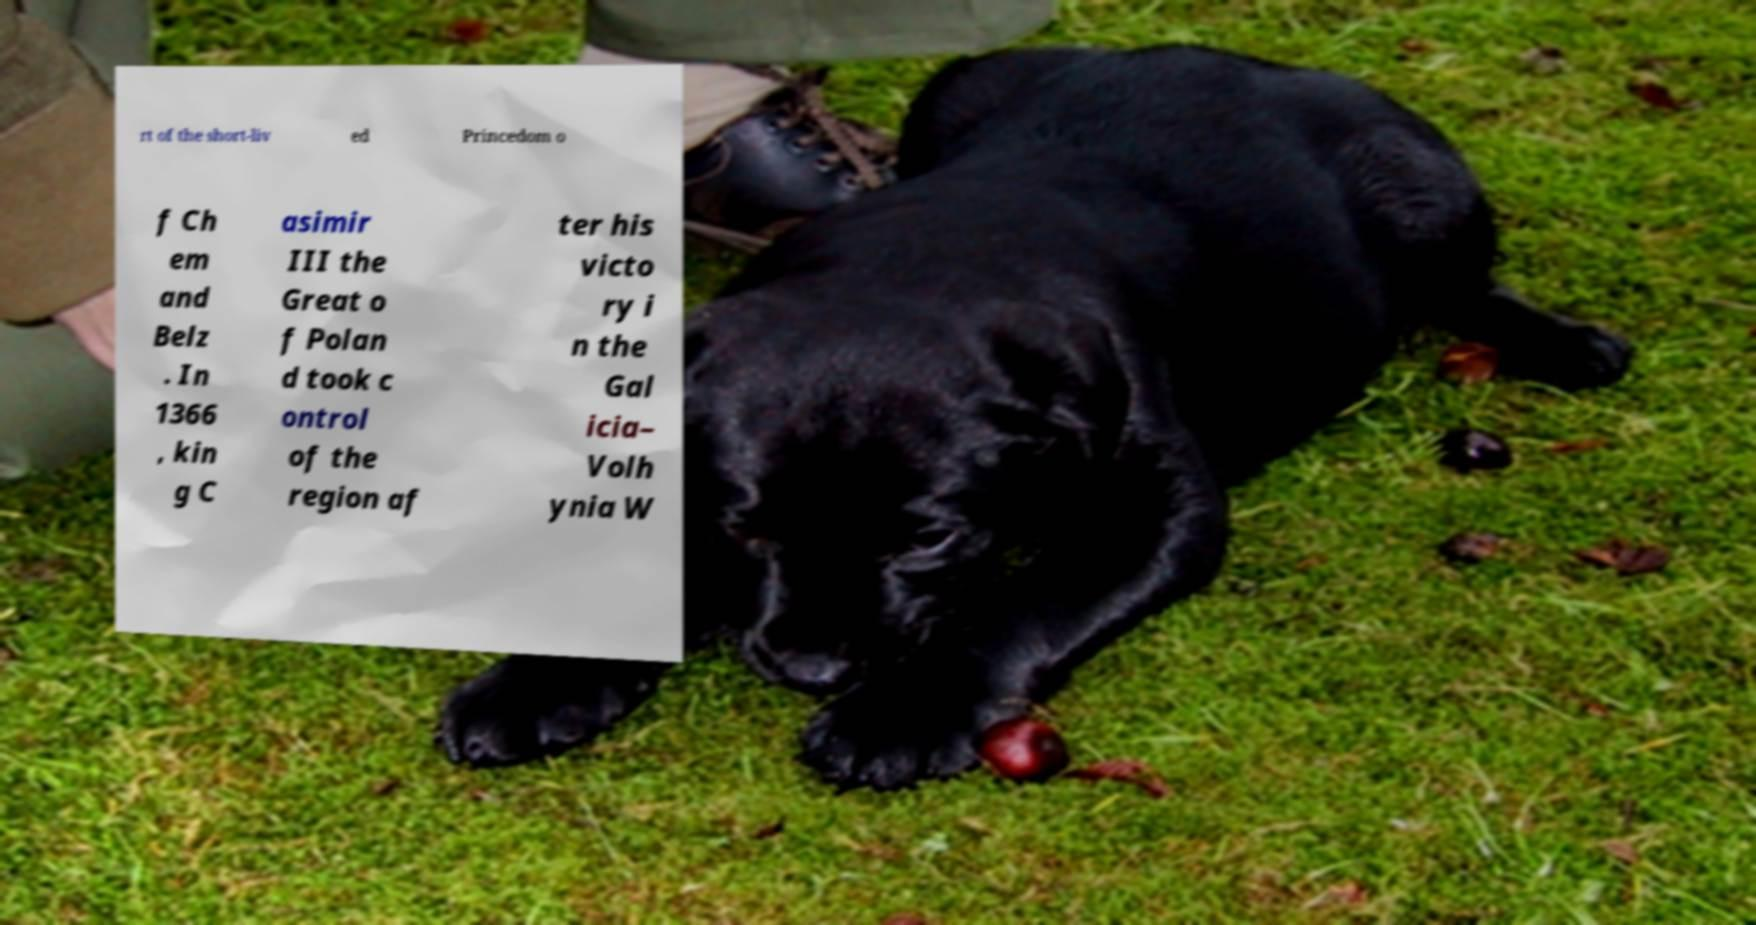There's text embedded in this image that I need extracted. Can you transcribe it verbatim? rt of the short-liv ed Princedom o f Ch em and Belz . In 1366 , kin g C asimir III the Great o f Polan d took c ontrol of the region af ter his victo ry i n the Gal icia– Volh ynia W 